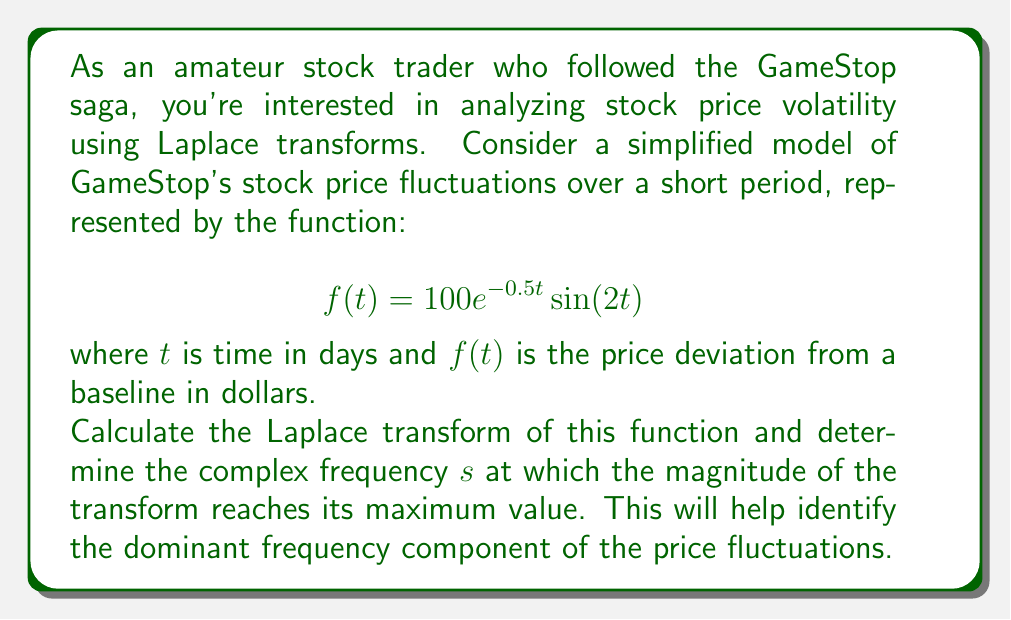Show me your answer to this math problem. Let's approach this step-by-step:

1) The Laplace transform of $f(t)$ is given by:
   $$F(s) = \mathcal{L}\{f(t)\} = \int_0^\infty f(t)e^{-st}dt$$

2) Substituting our function:
   $$F(s) = \int_0^\infty 100e^{-0.5t}\sin(2t)e^{-st}dt$$

3) This can be rewritten as:
   $$F(s) = 100\int_0^\infty e^{-(s+0.5)t}\sin(2t)dt$$

4) The Laplace transform of $e^{at}\sin(bt)$ is known to be:
   $$\mathcal{L}\{e^{at}\sin(bt)\} = \frac{b}{(s-a)^2 + b^2}$$

5) In our case, $a = -0.5$ and $b = 2$. Substituting:
   $$F(s) = 100 \cdot \frac{2}{(s+0.5)^2 + 2^2} = \frac{200}{(s+0.5)^2 + 4}$$

6) To find the maximum magnitude, we need to find where $|F(s)|$ is maximum. The magnitude is:
   $$|F(s)| = \frac{200}{\sqrt{((s+0.5)^2 + 4)^2}}$$

7) This will be maximum when the denominator is minimum. The denominator is minimum when $s = -0.5$, as this makes the $(s+0.5)^2$ term zero.

8) Therefore, the complex frequency $s$ at which the magnitude of the transform reaches its maximum value is $s = -0.5$.
Answer: $s = -0.5$ 